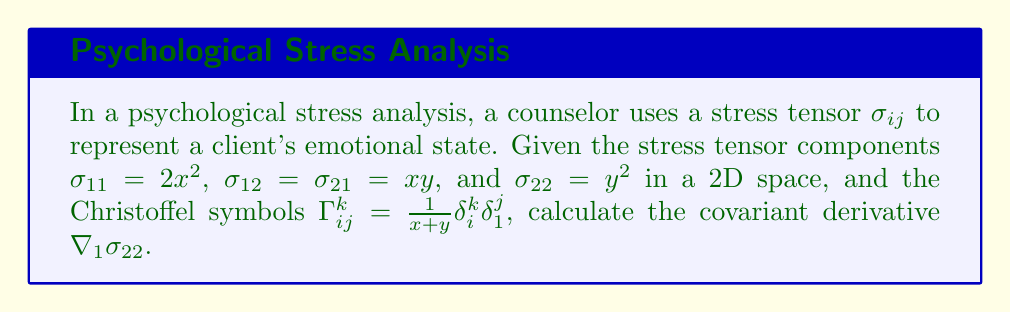Can you solve this math problem? To calculate the covariant derivative of the stress tensor component $\sigma_{22}$ with respect to the first coordinate (denoted by the subscript 1), we use the formula:

$$\nabla_1\sigma_{22} = \partial_1\sigma_{22} - \Gamma^k_{12}\sigma_{k2} - \Gamma^k_{21}\sigma_{2k}$$

Step 1: Calculate $\partial_1\sigma_{22}$
$\sigma_{22} = y^2$, so $\partial_1\sigma_{22} = 0$

Step 2: Calculate $\Gamma^k_{12}\sigma_{k2}$
$\Gamma^k_{12} = \frac{1}{x+y}\delta^k_1\delta^2_1 = 0$ (since $\delta^2_1 = 0$)
Therefore, $\Gamma^k_{12}\sigma_{k2} = 0$

Step 3: Calculate $\Gamma^k_{21}\sigma_{2k}$
$\Gamma^k_{21} = \frac{1}{x+y}\delta^k_2\delta^1_1 = \frac{1}{x+y}\delta^k_2$
$\Gamma^k_{21}\sigma_{2k} = \frac{1}{x+y}\sigma_{22} = \frac{y^2}{x+y}$

Step 4: Combine the results
$$\nabla_1\sigma_{22} = 0 - 0 - \frac{y^2}{x+y} = -\frac{y^2}{x+y}$$
Answer: $-\frac{y^2}{x+y}$ 